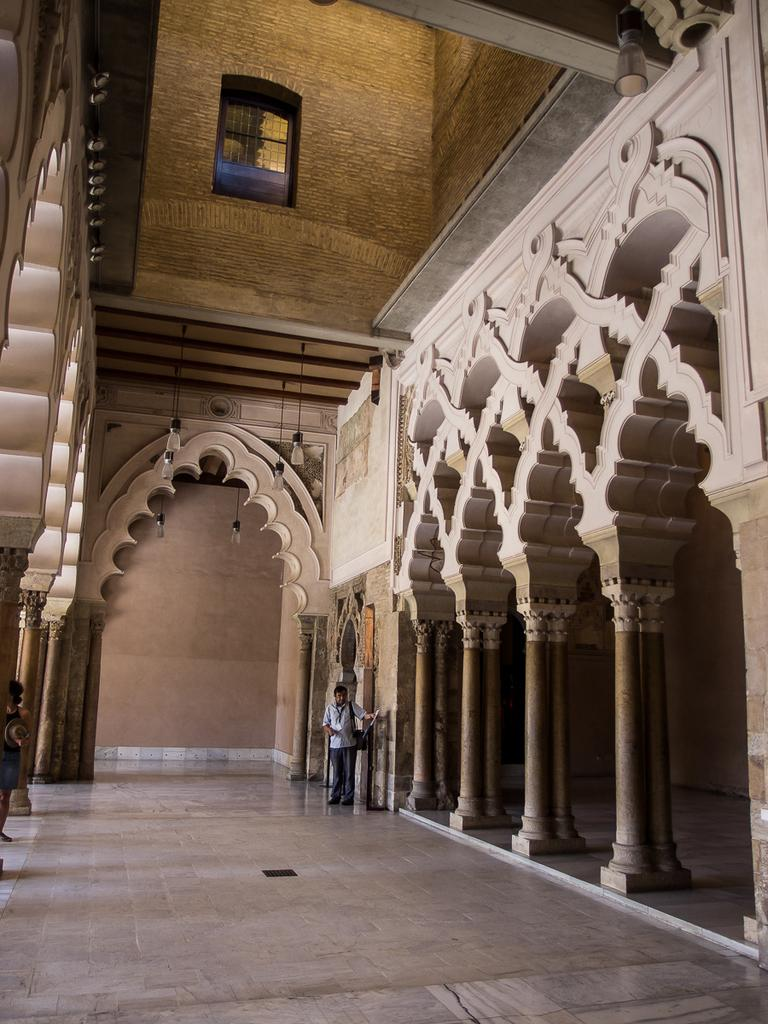What type of view is shown in the image? The image shows the inner view of a building. What can be seen hanging from the top in the image? There are electric lights hanging from the top in the image. What architectural feature allows natural light to enter the building? There are windows visible in the image. Can you describe the person in the image? A person is standing on the floor in the image. What structural elements support the building's roof? Pillars are present in the image. What type of brass instrument is being played by the person in the image? There is no brass instrument or person playing an instrument present in the image. 